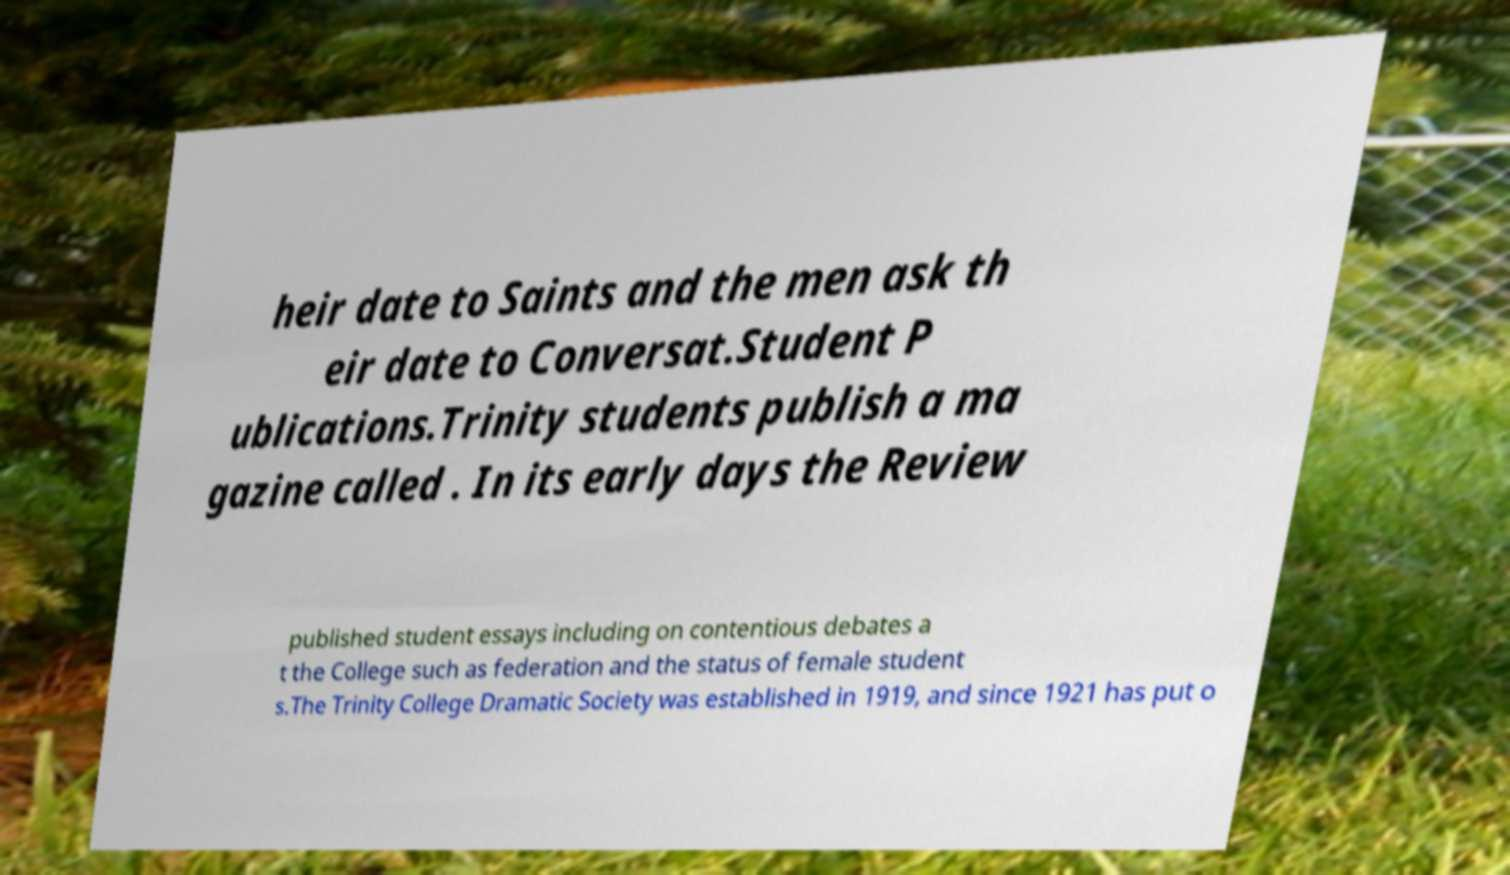Can you read and provide the text displayed in the image?This photo seems to have some interesting text. Can you extract and type it out for me? heir date to Saints and the men ask th eir date to Conversat.Student P ublications.Trinity students publish a ma gazine called . In its early days the Review published student essays including on contentious debates a t the College such as federation and the status of female student s.The Trinity College Dramatic Society was established in 1919, and since 1921 has put o 